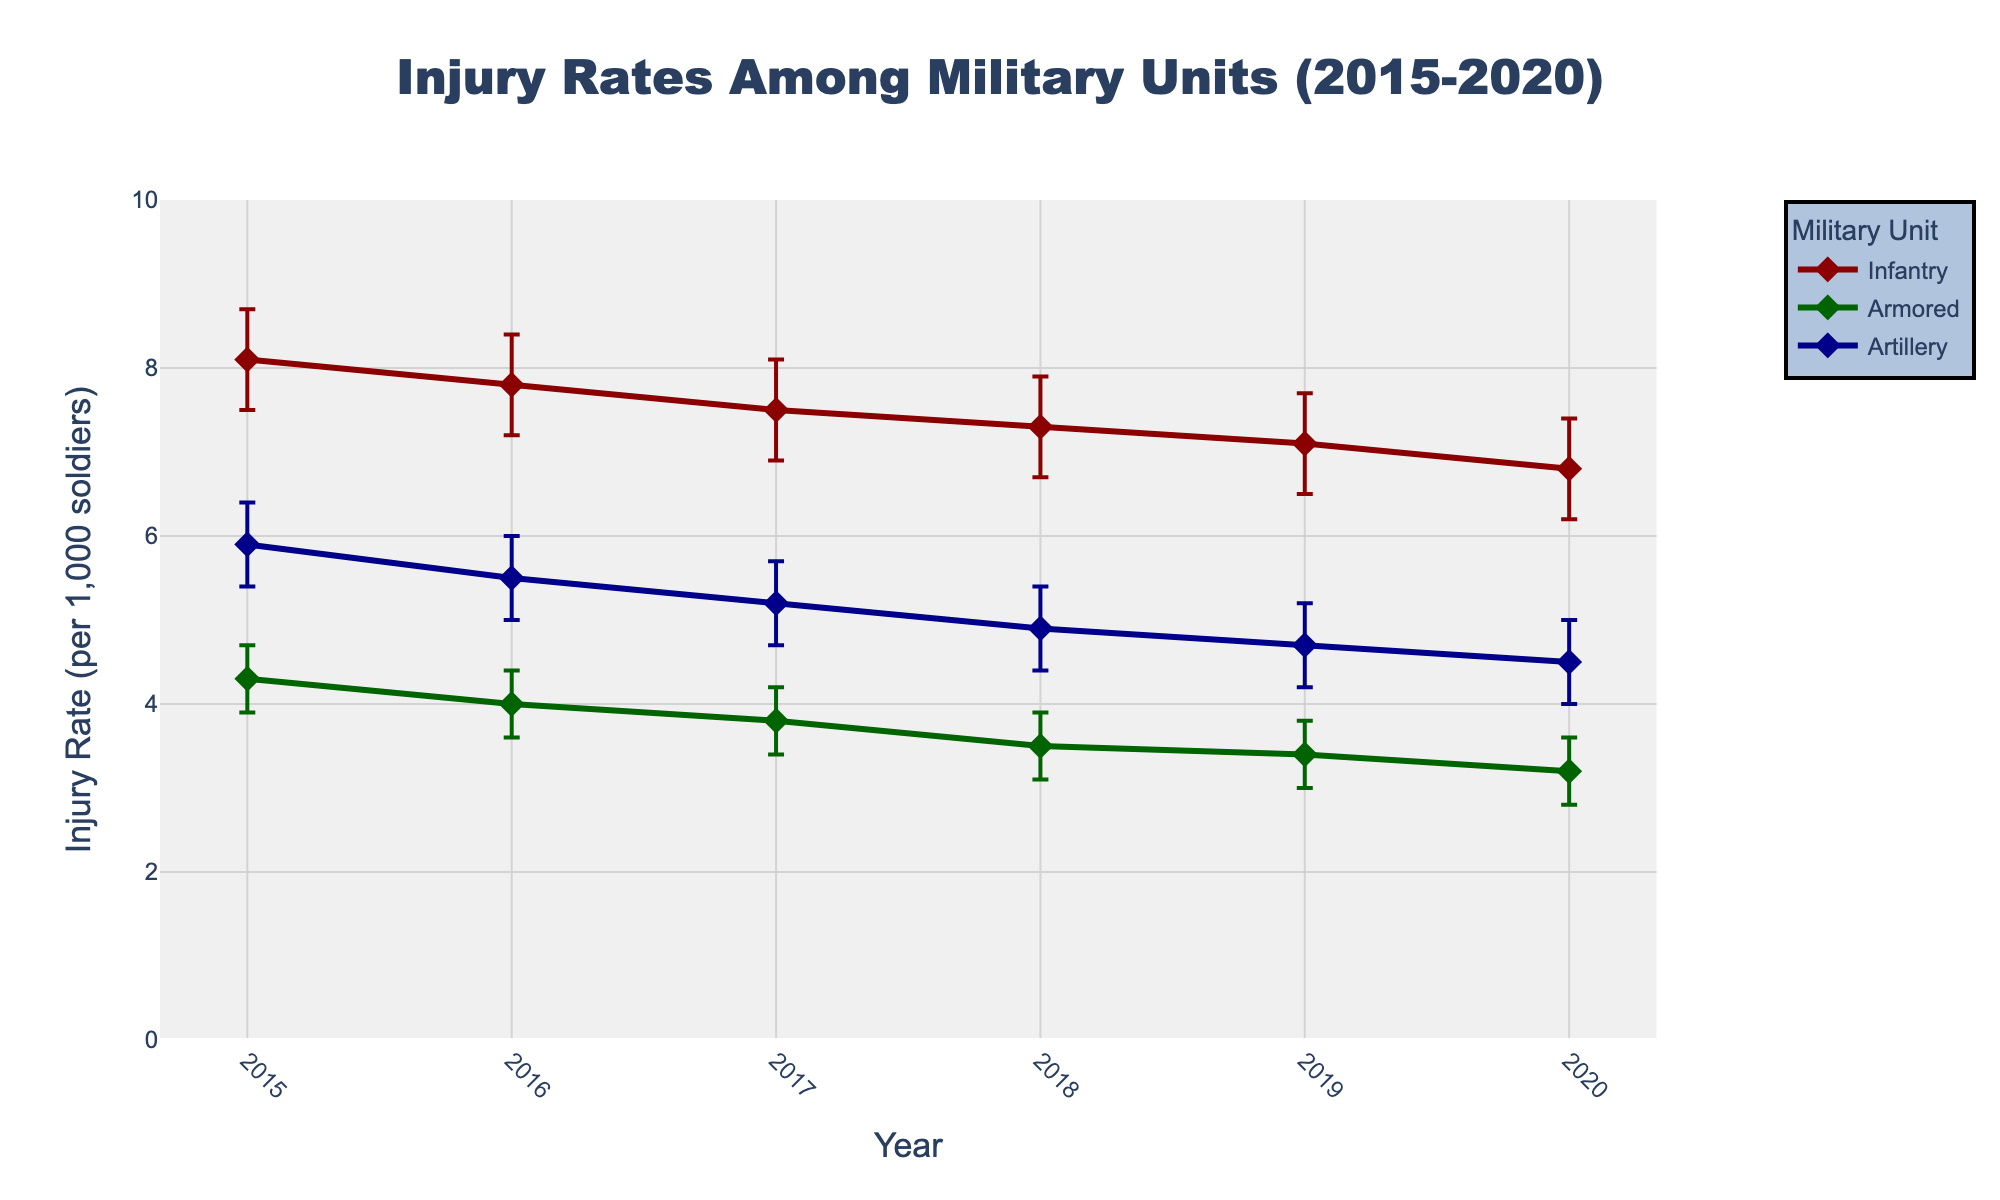What is the title of the figure? The title of the figure is usually found at the top and provides a summary of the contents. By looking at the top of the figure, one would see "Injury Rates Among Military Units (2015-2020)."
Answer: Injury Rates Among Military Units (2015-2020) Which unit has the highest injury rate in 2020? To find this, look at the plot for the year 2020 and identify the highest point among the units. The Infantry unit has the highest point in 2020 with an injury rate of 6.8.
Answer: Infantry How many years of data are plotted in the figure? The number of data points along the x-axis represents the years of data. By counting the years from 2015 to 2020, there are 6 years in total.
Answer: 6 What is the injury rate of the Artillery unit in 2016? Locate the Artillery unit's line and mark for the year 2016. The injury rate is shown to be 5.5.
Answer: 5.5 Which unit shows a consistent decrease in injury rate from 2015 to 2020? Compare the trends of all the units from 2015 to 2020. The Armored unit shows a consistent decrease in injury rate over this period.
Answer: Armored What is the range of injury rates for the Infantry unit over the entire period? Identify the highest and lowest points for the Infantry unit from 2015 to 2020. The range is from the highest point 8.1 in 2015 to the lowest point 6.8 in 2020.
Answer: 6.8 to 8.1 What is the average injury rate of the Armored unit from 2015 to 2020? Sum the injury rates of the Armored unit for each year and divide by the number of years. (4.3 + 4.0 + 3.8 + 3.5 + 3.4 + 3.2) / 6 = 3.7.
Answer: 3.7 In which year did the Infantry unit experience the biggest drop in injury rate? Find the year-to-year changes in injury rates for the Infantry. The biggest drop is from 2015 to 2016, where it went from 8.1 to 7.8.
Answer: 2015 to 2016 What is the trend of injury rates for the Artillery unit? Observe the overall direction of the Artillery unit's line from 2015 to 2020. The line shows a decreasing trend across the years.
Answer: Decreasing What is the injury rate difference between the Armored unit and the Artillery unit in 2019? Subtract the injury rate of the Armored unit from the Artillery unit for 2019: 4.7 - 3.4 = 1.3
Answer: 1.3 